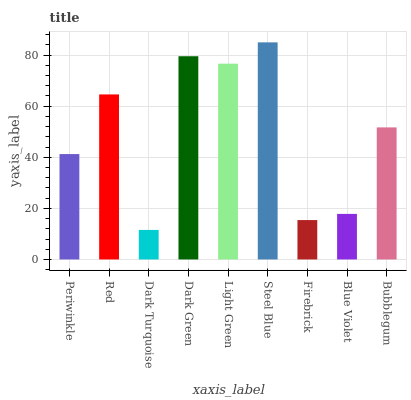Is Dark Turquoise the minimum?
Answer yes or no. Yes. Is Steel Blue the maximum?
Answer yes or no. Yes. Is Red the minimum?
Answer yes or no. No. Is Red the maximum?
Answer yes or no. No. Is Red greater than Periwinkle?
Answer yes or no. Yes. Is Periwinkle less than Red?
Answer yes or no. Yes. Is Periwinkle greater than Red?
Answer yes or no. No. Is Red less than Periwinkle?
Answer yes or no. No. Is Bubblegum the high median?
Answer yes or no. Yes. Is Bubblegum the low median?
Answer yes or no. Yes. Is Dark Green the high median?
Answer yes or no. No. Is Dark Turquoise the low median?
Answer yes or no. No. 